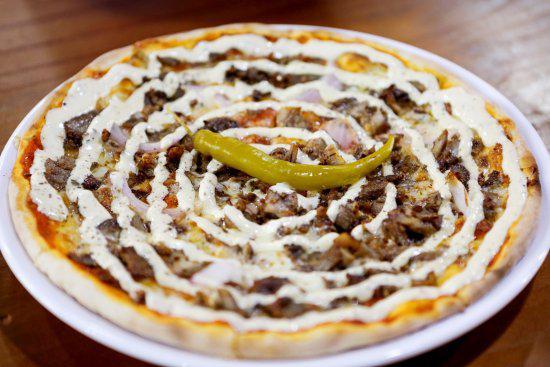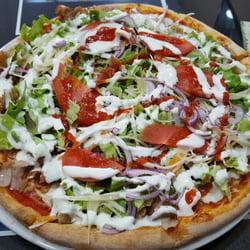The first image is the image on the left, the second image is the image on the right. Given the left and right images, does the statement "Each image shows a whole round pizza topped with a spiral of white cheese, and at least one pizza has a green chile pepper on top." hold true? Answer yes or no. Yes. The first image is the image on the left, the second image is the image on the right. Examine the images to the left and right. Is the description "Both pizzas have a drizzle of white sauce on top." accurate? Answer yes or no. Yes. 